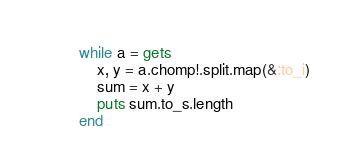Convert code to text. <code><loc_0><loc_0><loc_500><loc_500><_Ruby_>while a = gets
	x, y = a.chomp!.split.map(&:to_i)
	sum = x + y
	puts sum.to_s.length
end</code> 